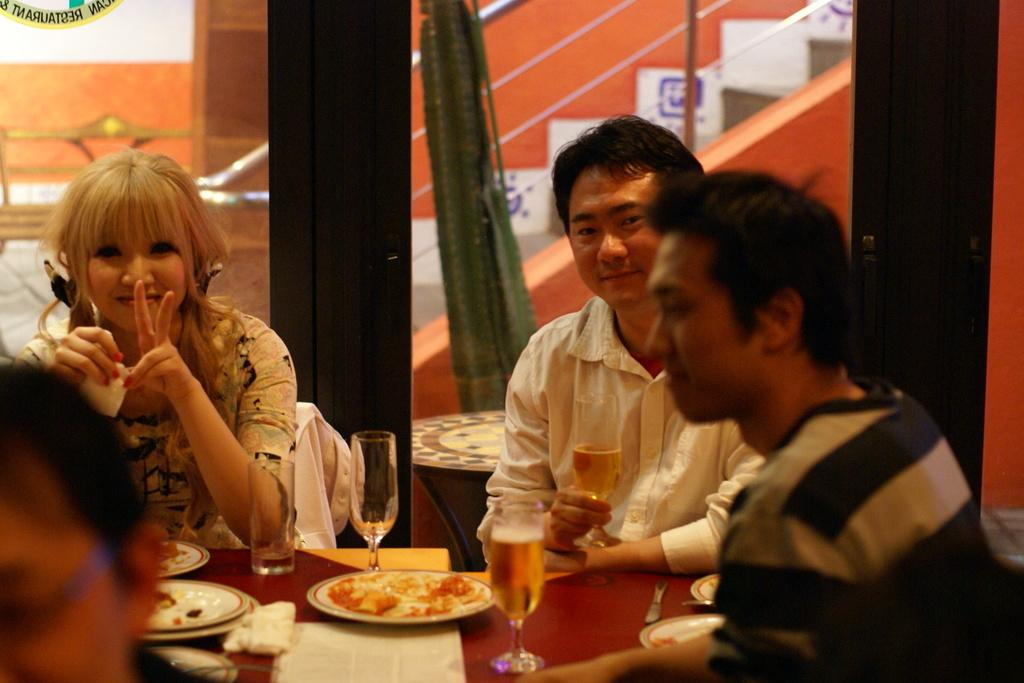How many people are in the image? There are four people in the image. What are the people doing in the image? The people are sitting on chairs. What is in front of the people? There is a table in front of the people. What items can be seen on the table? Plates and glasses are present on the table. What is visible behind the people? There are stairs behind the people. What type of scent can be detected in the image? There is no mention of a scent in the image, so it cannot be determined from the image. 